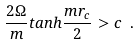Convert formula to latex. <formula><loc_0><loc_0><loc_500><loc_500>\frac { 2 \Omega } { m } t a n h \frac { m r _ { c } } { 2 } > c \ .</formula> 